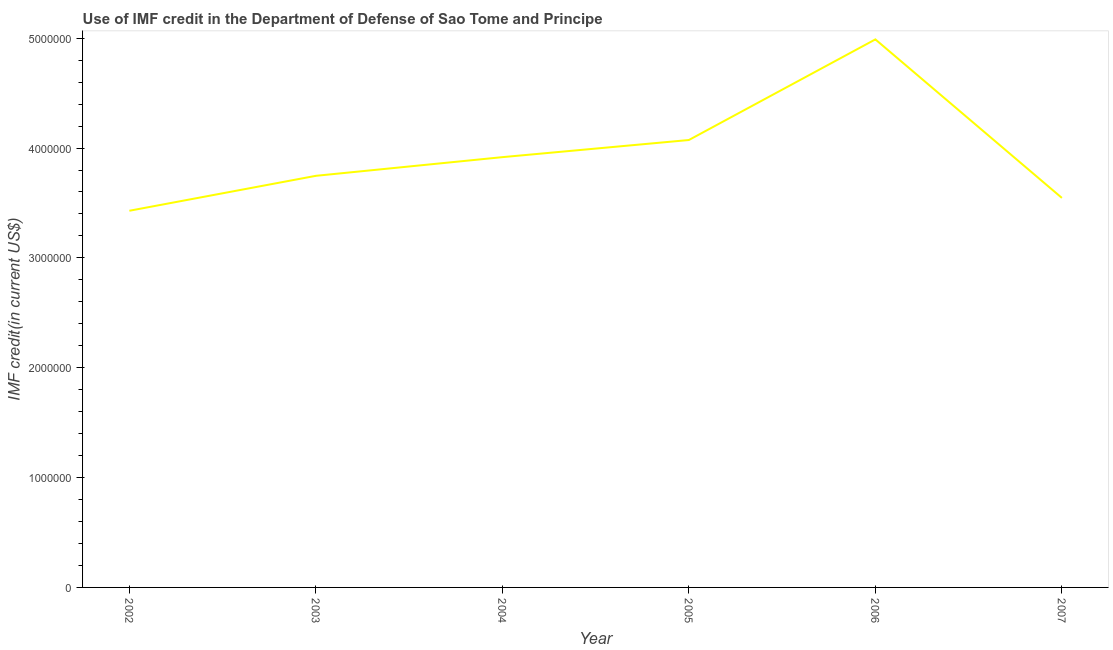What is the use of imf credit in dod in 2003?
Your answer should be compact. 3.75e+06. Across all years, what is the maximum use of imf credit in dod?
Offer a terse response. 4.99e+06. Across all years, what is the minimum use of imf credit in dod?
Ensure brevity in your answer.  3.43e+06. In which year was the use of imf credit in dod maximum?
Offer a terse response. 2006. In which year was the use of imf credit in dod minimum?
Provide a succinct answer. 2002. What is the sum of the use of imf credit in dod?
Offer a terse response. 2.37e+07. What is the difference between the use of imf credit in dod in 2002 and 2006?
Provide a succinct answer. -1.56e+06. What is the average use of imf credit in dod per year?
Make the answer very short. 3.95e+06. What is the median use of imf credit in dod?
Ensure brevity in your answer.  3.83e+06. In how many years, is the use of imf credit in dod greater than 1000000 US$?
Your answer should be compact. 6. What is the ratio of the use of imf credit in dod in 2006 to that in 2007?
Provide a short and direct response. 1.41. Is the difference between the use of imf credit in dod in 2005 and 2007 greater than the difference between any two years?
Provide a succinct answer. No. What is the difference between the highest and the second highest use of imf credit in dod?
Your answer should be compact. 9.16e+05. Is the sum of the use of imf credit in dod in 2002 and 2005 greater than the maximum use of imf credit in dod across all years?
Offer a terse response. Yes. What is the difference between the highest and the lowest use of imf credit in dod?
Offer a terse response. 1.56e+06. Does the use of imf credit in dod monotonically increase over the years?
Provide a succinct answer. No. How many lines are there?
Provide a succinct answer. 1. How many years are there in the graph?
Your answer should be compact. 6. Does the graph contain any zero values?
Ensure brevity in your answer.  No. Does the graph contain grids?
Offer a very short reply. No. What is the title of the graph?
Offer a terse response. Use of IMF credit in the Department of Defense of Sao Tome and Principe. What is the label or title of the Y-axis?
Your response must be concise. IMF credit(in current US$). What is the IMF credit(in current US$) in 2002?
Your answer should be compact. 3.43e+06. What is the IMF credit(in current US$) in 2003?
Offer a very short reply. 3.75e+06. What is the IMF credit(in current US$) of 2004?
Your response must be concise. 3.92e+06. What is the IMF credit(in current US$) of 2005?
Your response must be concise. 4.07e+06. What is the IMF credit(in current US$) in 2006?
Make the answer very short. 4.99e+06. What is the IMF credit(in current US$) in 2007?
Ensure brevity in your answer.  3.55e+06. What is the difference between the IMF credit(in current US$) in 2002 and 2003?
Provide a succinct answer. -3.18e+05. What is the difference between the IMF credit(in current US$) in 2002 and 2004?
Make the answer very short. -4.88e+05. What is the difference between the IMF credit(in current US$) in 2002 and 2005?
Your answer should be compact. -6.44e+05. What is the difference between the IMF credit(in current US$) in 2002 and 2006?
Keep it short and to the point. -1.56e+06. What is the difference between the IMF credit(in current US$) in 2002 and 2007?
Offer a terse response. -1.17e+05. What is the difference between the IMF credit(in current US$) in 2003 and 2004?
Offer a very short reply. -1.70e+05. What is the difference between the IMF credit(in current US$) in 2003 and 2005?
Make the answer very short. -3.26e+05. What is the difference between the IMF credit(in current US$) in 2003 and 2006?
Offer a terse response. -1.24e+06. What is the difference between the IMF credit(in current US$) in 2003 and 2007?
Give a very brief answer. 2.01e+05. What is the difference between the IMF credit(in current US$) in 2004 and 2005?
Offer a terse response. -1.56e+05. What is the difference between the IMF credit(in current US$) in 2004 and 2006?
Your response must be concise. -1.07e+06. What is the difference between the IMF credit(in current US$) in 2004 and 2007?
Give a very brief answer. 3.71e+05. What is the difference between the IMF credit(in current US$) in 2005 and 2006?
Your answer should be very brief. -9.16e+05. What is the difference between the IMF credit(in current US$) in 2005 and 2007?
Your response must be concise. 5.27e+05. What is the difference between the IMF credit(in current US$) in 2006 and 2007?
Ensure brevity in your answer.  1.44e+06. What is the ratio of the IMF credit(in current US$) in 2002 to that in 2003?
Offer a very short reply. 0.92. What is the ratio of the IMF credit(in current US$) in 2002 to that in 2005?
Offer a terse response. 0.84. What is the ratio of the IMF credit(in current US$) in 2002 to that in 2006?
Ensure brevity in your answer.  0.69. What is the ratio of the IMF credit(in current US$) in 2003 to that in 2004?
Provide a short and direct response. 0.96. What is the ratio of the IMF credit(in current US$) in 2003 to that in 2005?
Provide a succinct answer. 0.92. What is the ratio of the IMF credit(in current US$) in 2003 to that in 2006?
Give a very brief answer. 0.75. What is the ratio of the IMF credit(in current US$) in 2003 to that in 2007?
Your answer should be very brief. 1.06. What is the ratio of the IMF credit(in current US$) in 2004 to that in 2006?
Keep it short and to the point. 0.79. What is the ratio of the IMF credit(in current US$) in 2004 to that in 2007?
Give a very brief answer. 1.1. What is the ratio of the IMF credit(in current US$) in 2005 to that in 2006?
Ensure brevity in your answer.  0.82. What is the ratio of the IMF credit(in current US$) in 2005 to that in 2007?
Give a very brief answer. 1.15. What is the ratio of the IMF credit(in current US$) in 2006 to that in 2007?
Offer a very short reply. 1.41. 